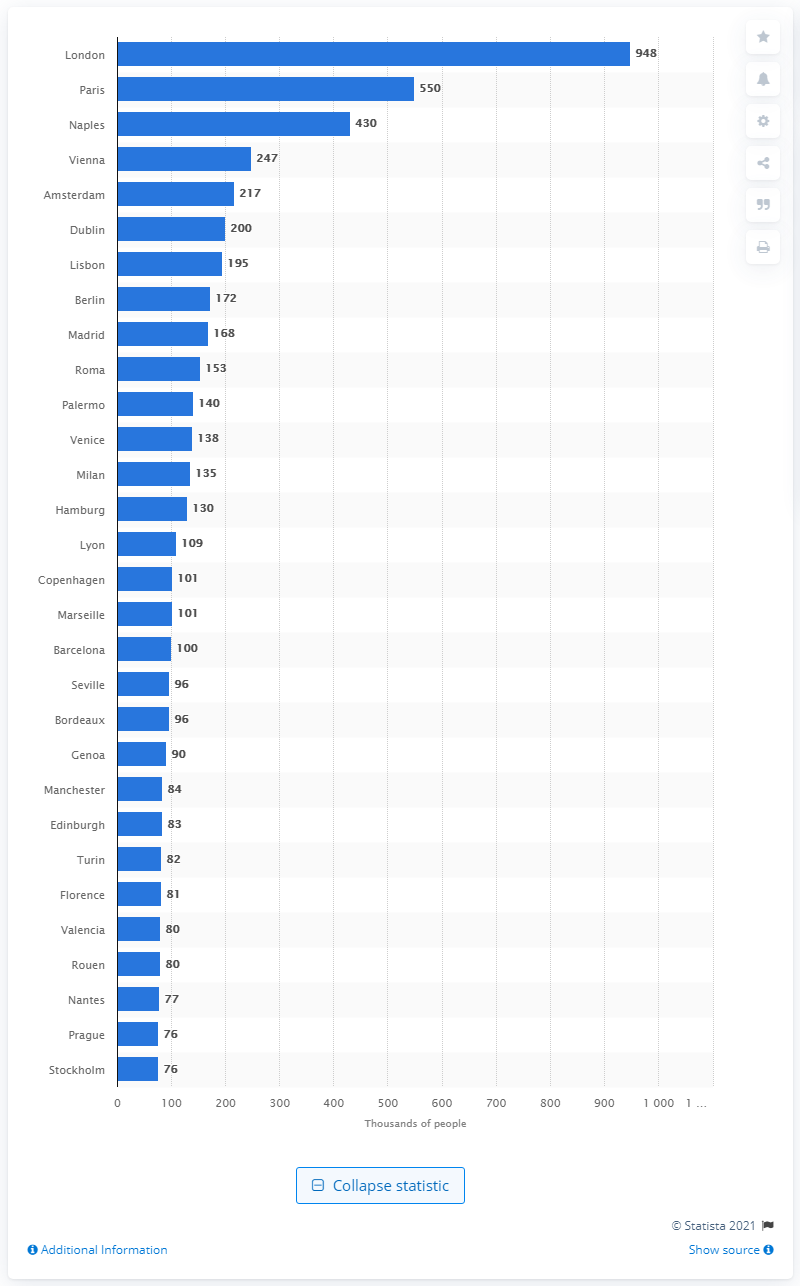Reflecting on this data, how might the large populations in these cities have influenced their cultural and political significance during the 1800s? The large populations of these cities would have had a profound impact on their cultural and political significance. With greater population density comes increased opportunities for cultural exchange and innovation, which often leads to advancements in arts, science, and technology. Moreover, these cities would have wielded considerable political power within their countries, as they were likely the centers of government, policy-making, and political discourse. The sheer number of inhabitants would also have made these cities crucial in terms of economic activity, shaping the overall prosperity and influence of their respective nations in the global arena. 